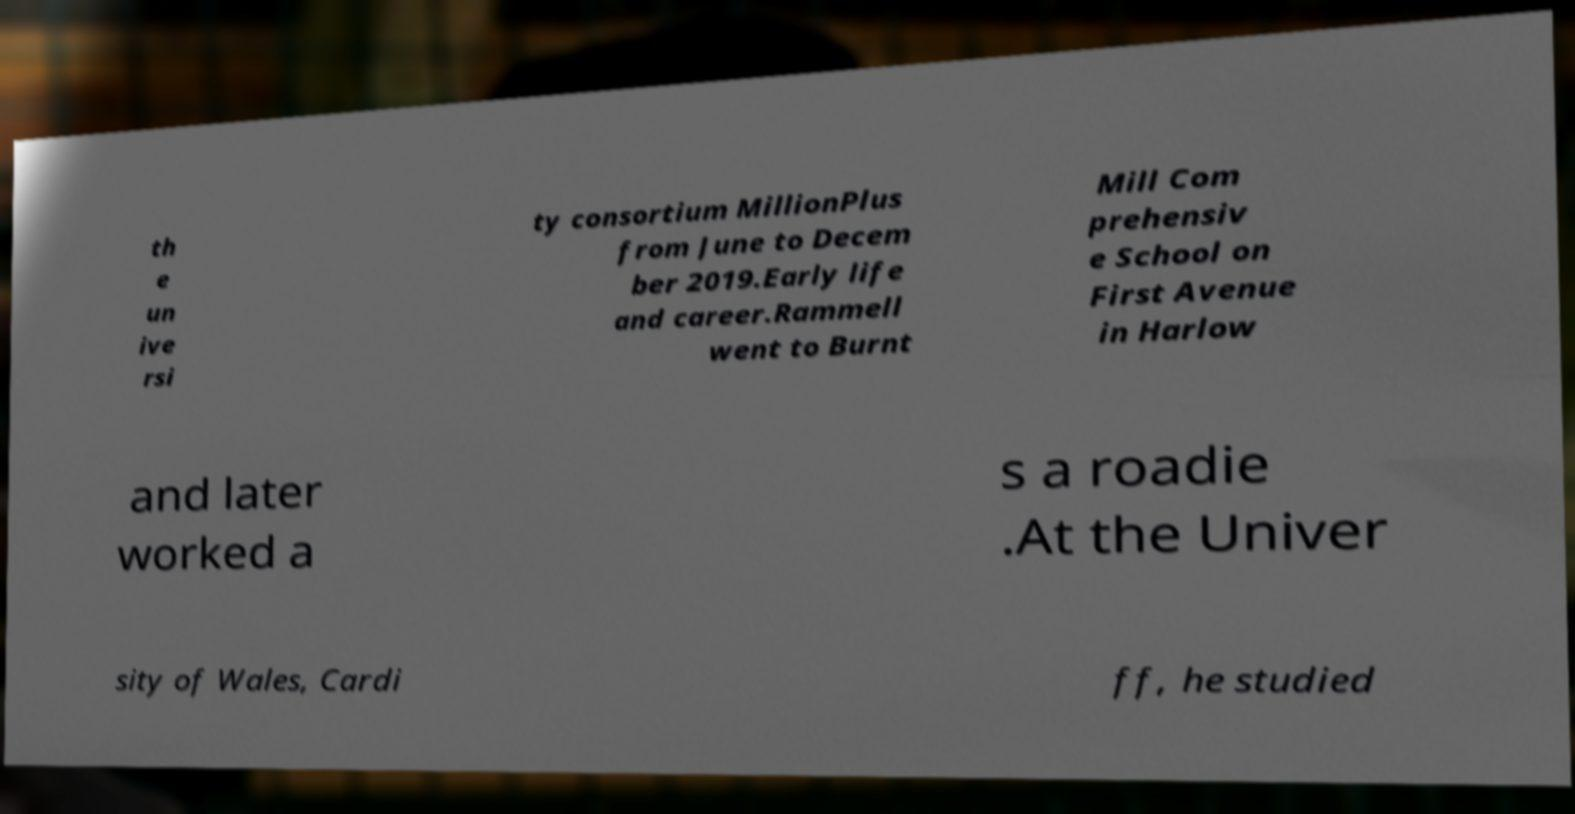There's text embedded in this image that I need extracted. Can you transcribe it verbatim? th e un ive rsi ty consortium MillionPlus from June to Decem ber 2019.Early life and career.Rammell went to Burnt Mill Com prehensiv e School on First Avenue in Harlow and later worked a s a roadie .At the Univer sity of Wales, Cardi ff, he studied 